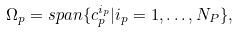Convert formula to latex. <formula><loc_0><loc_0><loc_500><loc_500>\Omega _ { p } = s p a n \{ c ^ { i _ { p } } _ { p } | i _ { p } = 1 , \dots , N _ { P } \} ,</formula> 